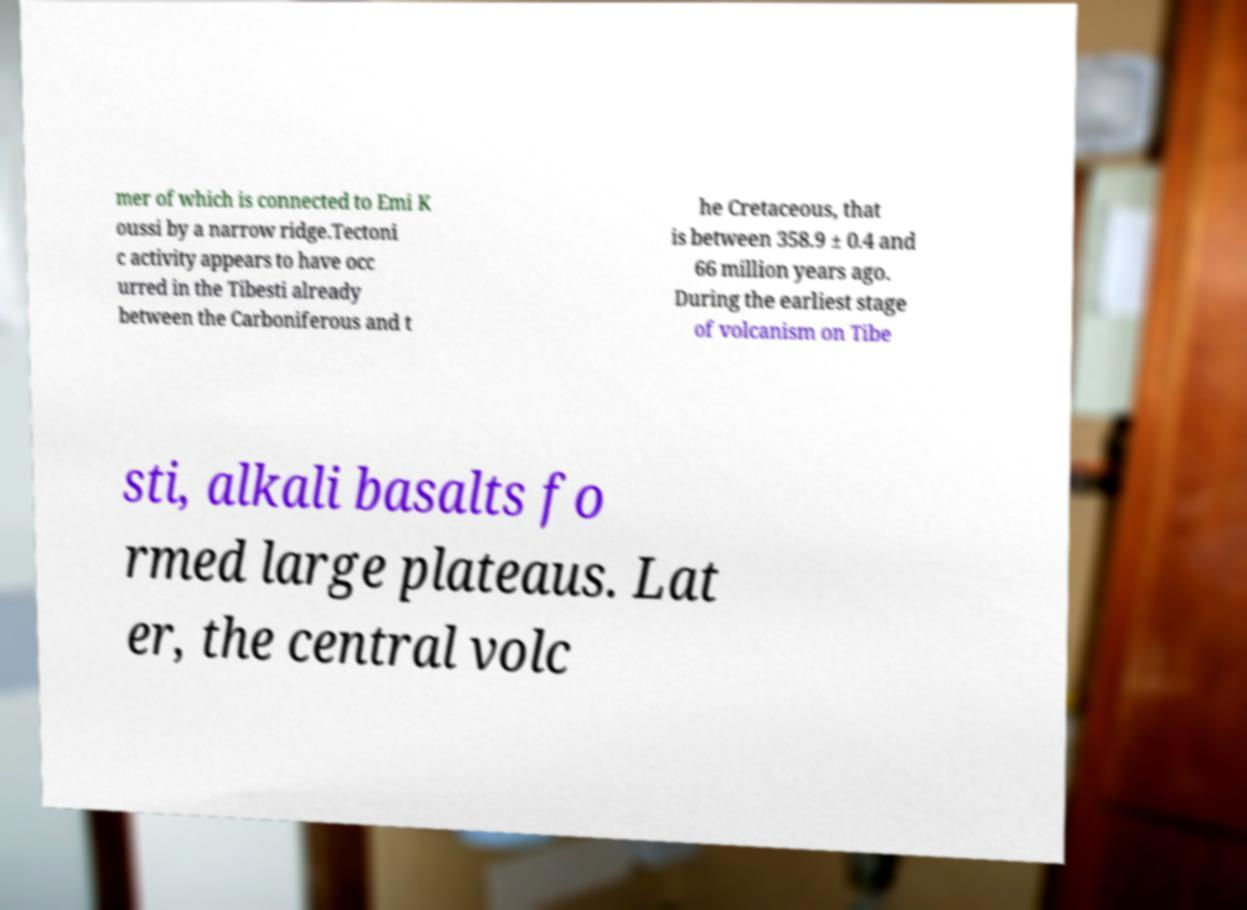There's text embedded in this image that I need extracted. Can you transcribe it verbatim? mer of which is connected to Emi K oussi by a narrow ridge.Tectoni c activity appears to have occ urred in the Tibesti already between the Carboniferous and t he Cretaceous, that is between 358.9 ± 0.4 and 66 million years ago. During the earliest stage of volcanism on Tibe sti, alkali basalts fo rmed large plateaus. Lat er, the central volc 